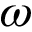<formula> <loc_0><loc_0><loc_500><loc_500>\omega</formula> 